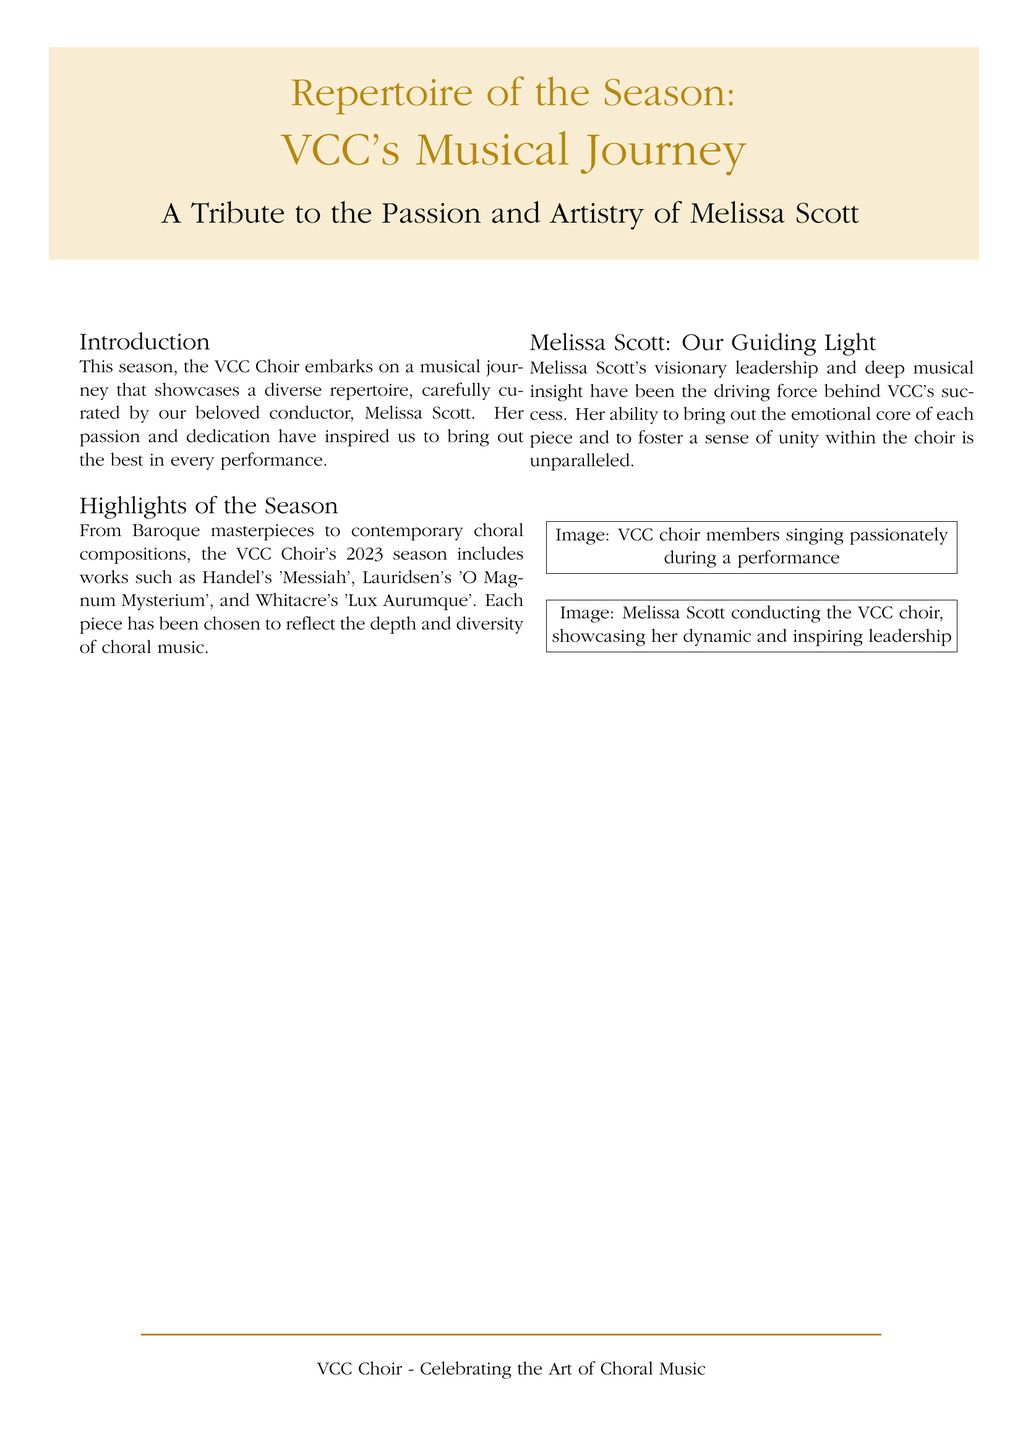What is the title of the book? The title is prominently displayed at the top of the document, indicating the main subject of the content.
Answer: Repertoire of the Season Who is the conductor featured in the document? The document highlights the key individual leading the choir throughout the season.
Answer: Melissa Scott What is the primary theme of the book? The book focuses on the journey of a choir, as indicated in the title and introduction.
Answer: VCC's Musical Journey Which famous choral work by Handel is included in the season's repertoire? The document explicitly lists notable works featured in the choir's performances.
Answer: Messiah What type of musical compositions are included in the season? The introduction specifies a range of styles represented in the choir's selections.
Answer: Diverse repertoire How does Melissa Scott contribute to the choir? The document describes her impact on the choir and its success, providing insight into her role.
Answer: Guiding light What color is used for the title text? The design choices are noted, including the color scheme of the text.
Answer: Dark gold What image is depicted alongside the title? The document mentions images that illustrate the performances associated with the choir.
Answer: Choir members singing What is the subtitle of the book? The document features a subtitle that elaborates on the main title's focus.
Answer: A Tribute to the Passion and Artistry of Melissa Scott 